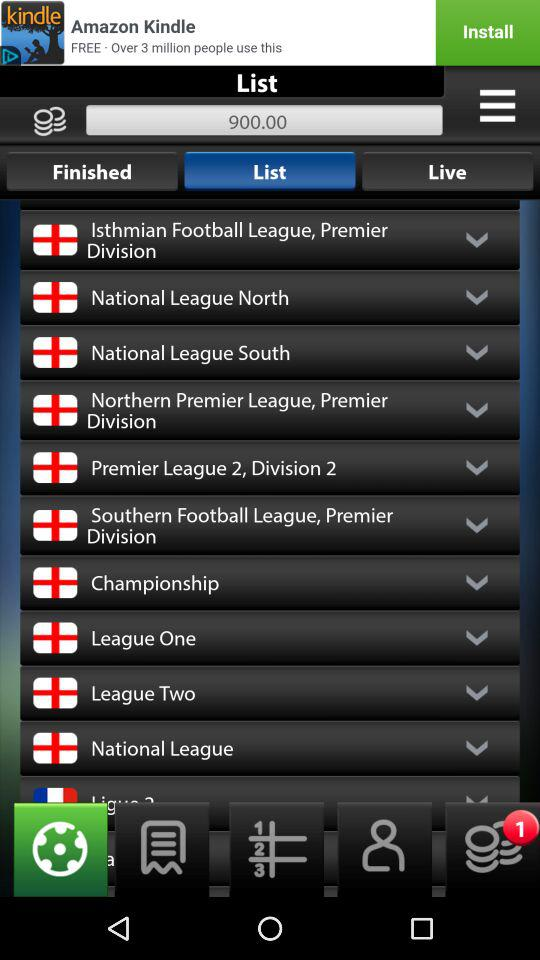How many pending notifications are there? There is 1 pending notification. 